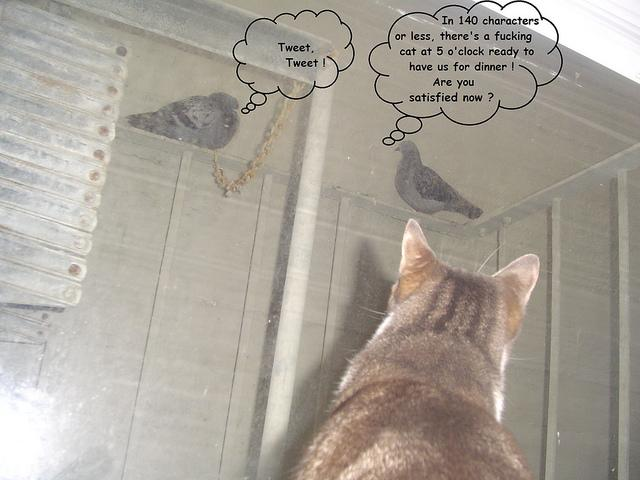The dialogue bubbles are an example of what editing technique? thinking 